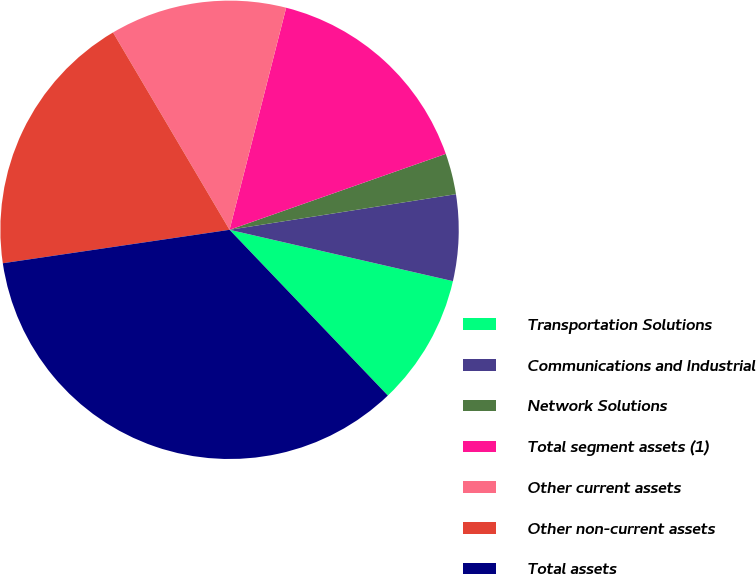Convert chart. <chart><loc_0><loc_0><loc_500><loc_500><pie_chart><fcel>Transportation Solutions<fcel>Communications and Industrial<fcel>Network Solutions<fcel>Total segment assets (1)<fcel>Other current assets<fcel>Other non-current assets<fcel>Total assets<nl><fcel>9.27%<fcel>6.08%<fcel>2.89%<fcel>15.65%<fcel>12.46%<fcel>18.84%<fcel>34.8%<nl></chart> 